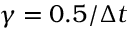<formula> <loc_0><loc_0><loc_500><loc_500>\gamma = 0 . 5 / \Delta t</formula> 